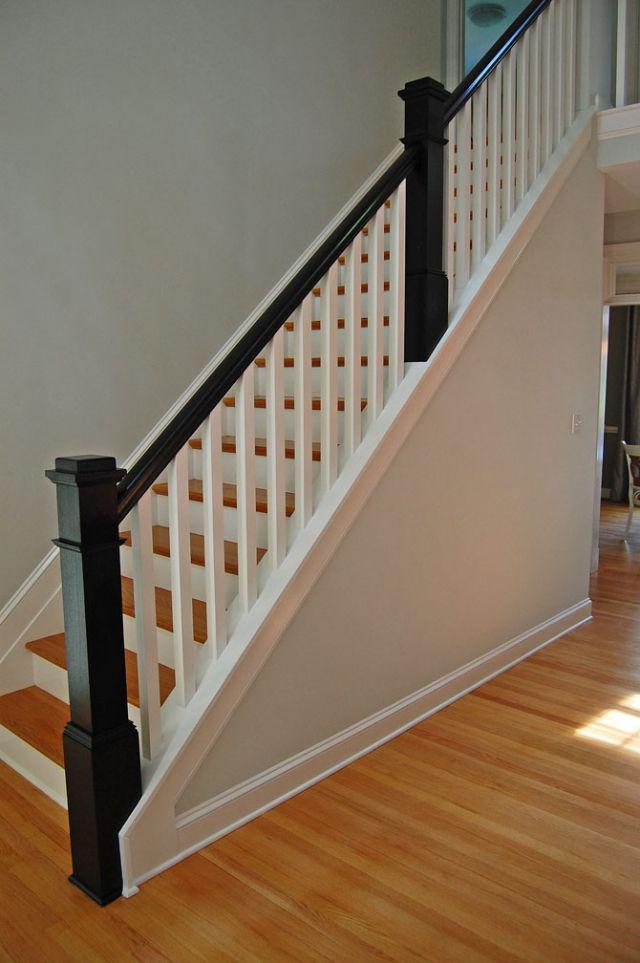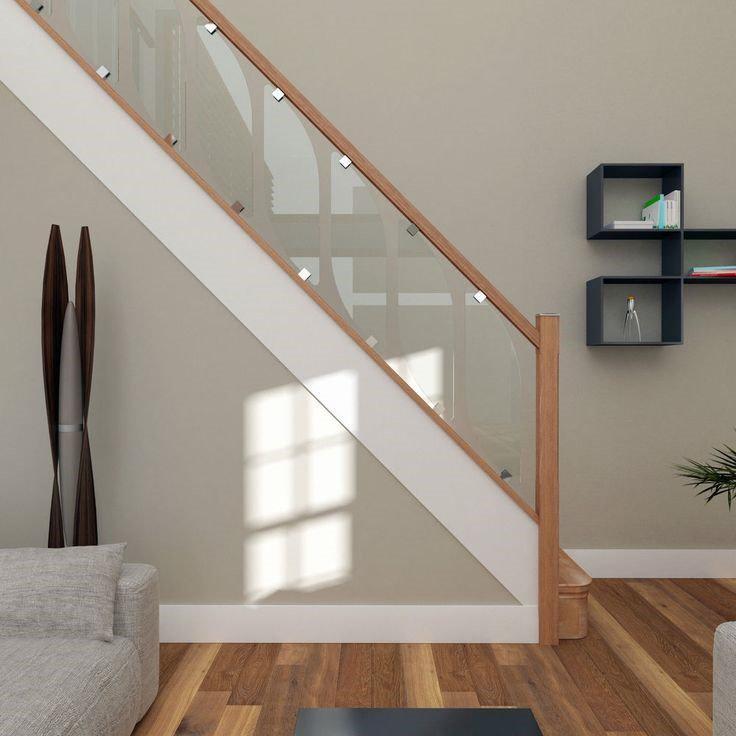The first image is the image on the left, the second image is the image on the right. Assess this claim about the two images: "Each image shows a staircase that ascends to the right and has a wooden banister with only vertical bars and a closed-in bottom.". Correct or not? Answer yes or no. No. 